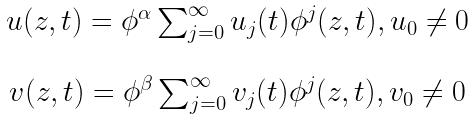Convert formula to latex. <formula><loc_0><loc_0><loc_500><loc_500>\begin{array} { c } u ( z , t ) = \phi ^ { \alpha } \sum _ { j = 0 } ^ { \infty } u _ { j } ( t ) \phi ^ { j } ( z , t ) , u _ { 0 } \neq 0 \\ \\ v ( z , t ) = \phi ^ { \beta } \sum _ { j = 0 } ^ { \infty } v _ { j } ( t ) \phi ^ { j } ( z , t ) , v _ { 0 } \neq 0 \end{array}</formula> 